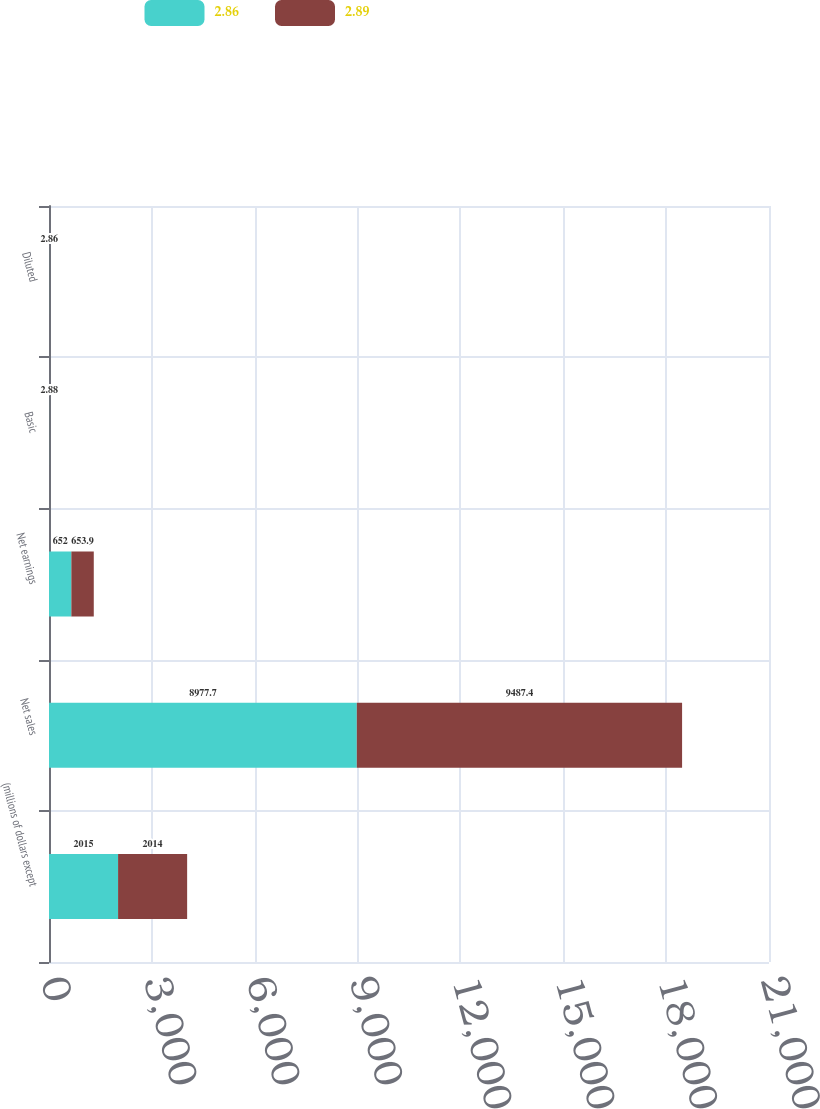Convert chart. <chart><loc_0><loc_0><loc_500><loc_500><stacked_bar_chart><ecel><fcel>(millions of dollars except<fcel>Net sales<fcel>Net earnings<fcel>Basic<fcel>Diluted<nl><fcel>2.86<fcel>2015<fcel>8977.7<fcel>652<fcel>2.91<fcel>2.89<nl><fcel>2.89<fcel>2014<fcel>9487.4<fcel>653.9<fcel>2.88<fcel>2.86<nl></chart> 